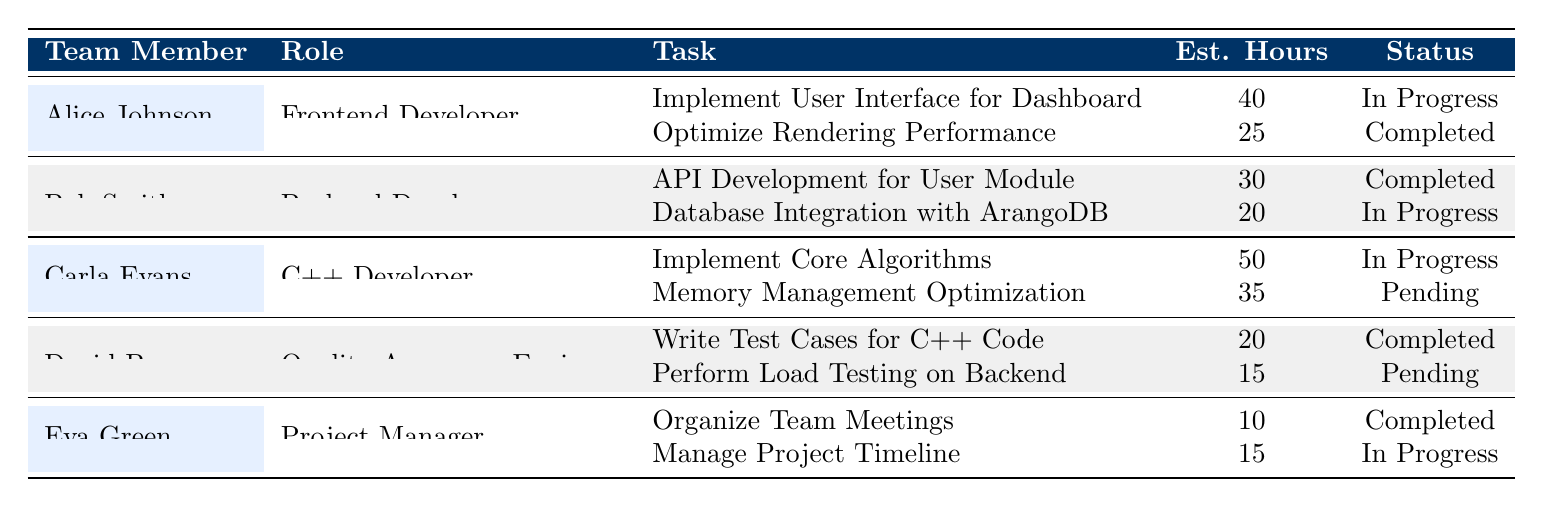What is the total number of estimated hours for all tasks assigned to Carla Evans? Carla Evans has two tasks: "Implement Core Algorithms" with 50 hours and "Memory Management Optimization" with 35 hours. Adding these gives us a total of 50 + 35 = 85 hours.
Answer: 85 How many tasks has Alice Johnson completed? Alice Johnson has two tasks: "Implement User Interface for Dashboard" (In Progress) and "Optimize Rendering Performance" (Completed). Only one of her tasks is marked as Completed.
Answer: 1 Which team member is working on the most tasks? Each team member is assigned two tasks, so no one is working on more than two tasks. Therefore, all team members are working on the same number of tasks.
Answer: None What percentage of tasks for the team are marked as "In Progress"? There are a total of 10 tasks across all team members. Out of these, 5 are marked as "In Progress" (Alice has 1, Bob has 1, Carla has 1, Eva has 1). The percentage is calculated as (5 / 10) * 100 = 50%.
Answer: 50% Is Bob Smith’s "Database Integration with ArangoDB" task the only one that is currently in progress for backend development? Bob Smith has two tasks: "API Development for User Module" (Completed) and "Database Integration with ArangoDB" (In Progress). Hence, it is indeed the only one currently in progress for backend development since he has no other tasks in progress.
Answer: Yes What is the total estimated hours for all completed tasks? The completed tasks are: "Optimize Rendering Performance" (25 hours), "API Development for User Module" (30 hours), "Write Test Cases for C++ Code" (20 hours), "Organize Team Meetings" (10 hours). Summing these gives us 25 + 30 + 20 + 10 = 95 hours.
Answer: 95 Who has the highest estimated hours for a single task? Carla Evans has the task "Implement Core Algorithms" with the highest estimated hours of 50. No one has a task with more estimated hours than this.
Answer: Carla Evans What is the average estimated hours for tasks assigned to the Team Members? There are a total of 10 tasks with a sum of estimated hours: 40 + 25 + 30 + 20 + 50 + 35 + 20 + 15 + 10 + 15 = 250 hours. Dividing this by the number of tasks (10), the average is 250 / 10 = 25 hours.
Answer: 25 Which roles do not have any tasks pending? The roles of Frontend Developer, Backend Developer, and Project Manager have no pending tasks. The Quality Assurance Engineer and C++ Developer both have tasks marked as pending.
Answer: Frontend Developer, Backend Developer, Project Manager How many tasks does the Quality Assurance Engineer need to complete? David Brown, the Quality Assurance Engineer, has two tasks. One task, "Write Test Cases for C++ Code," is completed, while the other task, "Perform Load Testing on Backend," is pending. Therefore, he needs to complete one task.
Answer: 1 Is there any task related to performance optimization? Yes, both "Optimize Rendering Performance" (assigned to Alice Johnson) and "Memory Management Optimization" (assigned to Carla Evans) are related to performance optimization.
Answer: Yes 